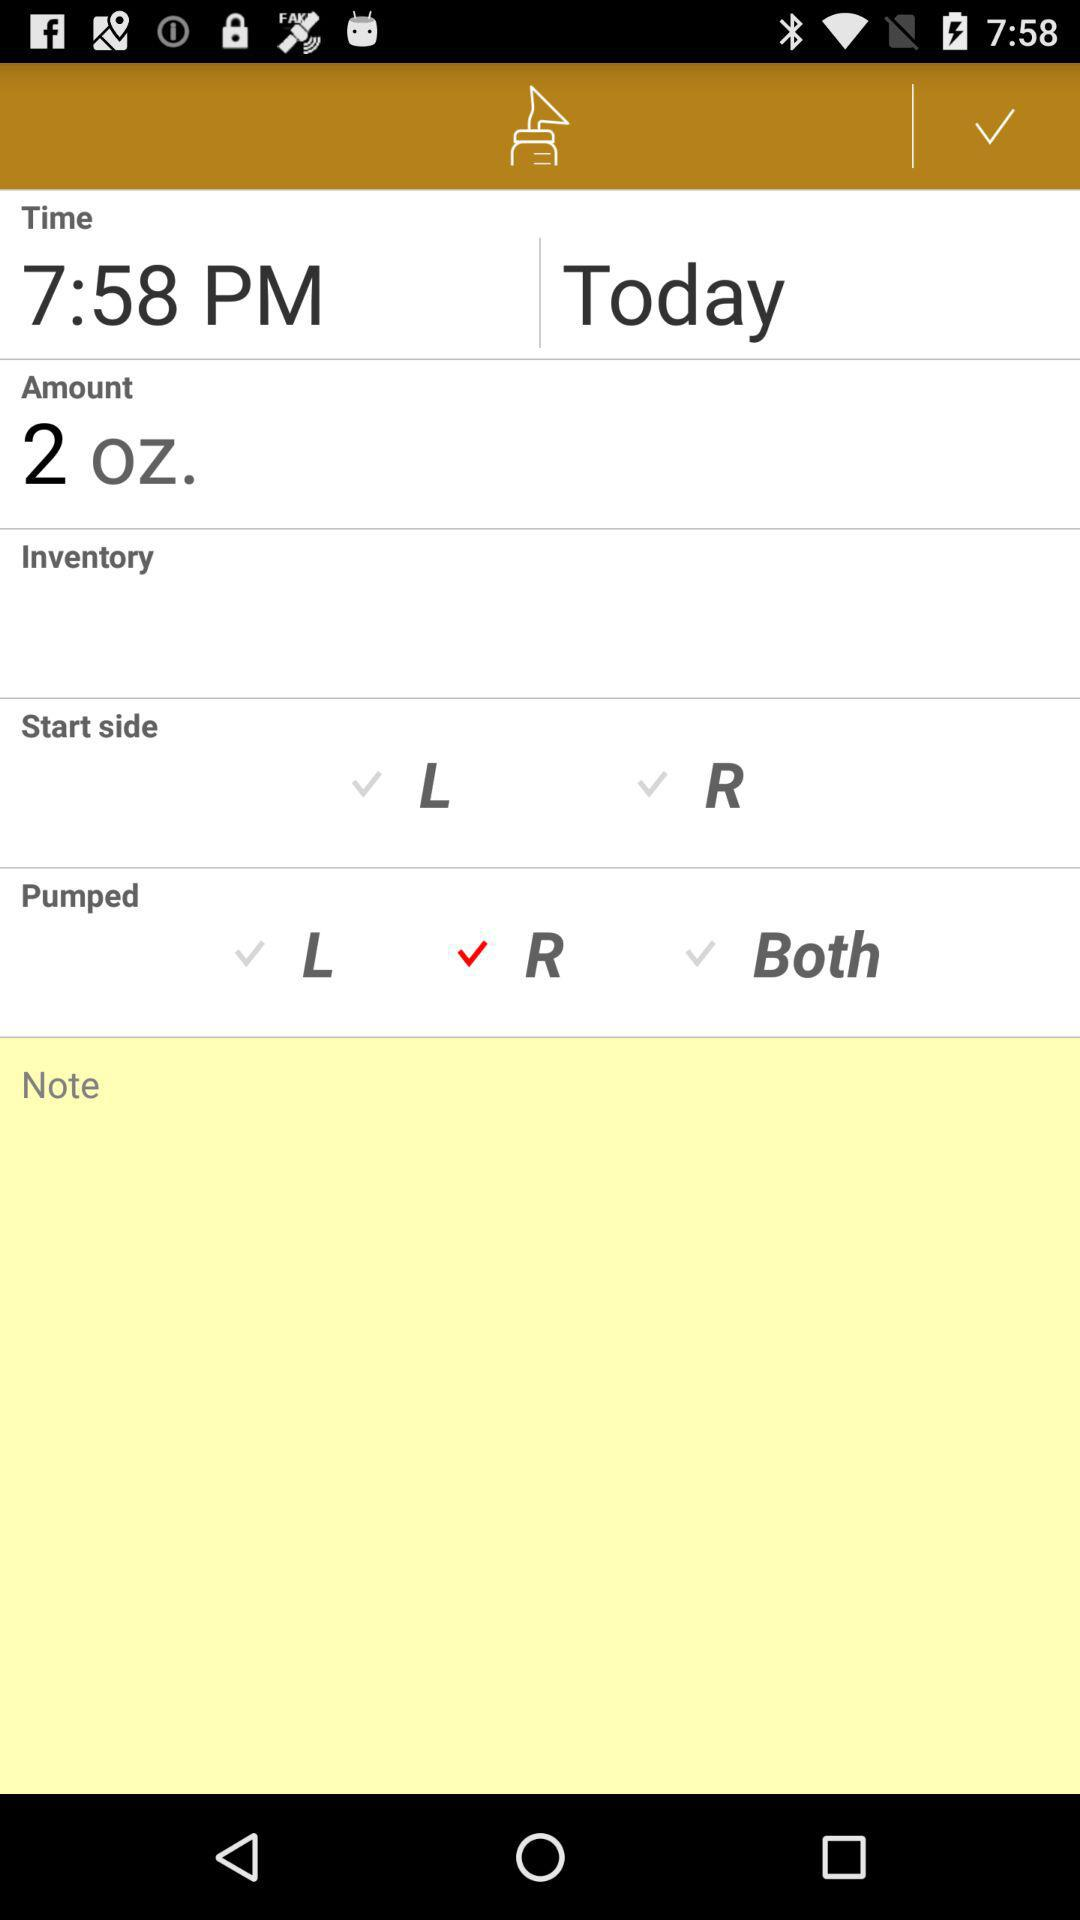What is the time? The time is 7:58 PM. 